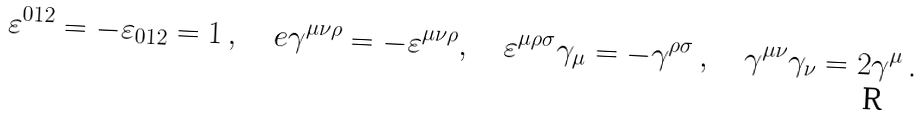Convert formula to latex. <formula><loc_0><loc_0><loc_500><loc_500>\varepsilon ^ { 0 1 2 } = - \varepsilon _ { 0 1 2 } = 1 \, , \quad e \gamma ^ { \mu \nu \rho } = - \varepsilon ^ { \mu \nu \rho } , \quad \varepsilon ^ { \mu \rho \sigma } \gamma _ { \mu } = - \gamma ^ { \rho \sigma } \, , \quad \gamma ^ { \mu \nu } \gamma _ { \nu } = 2 \gamma ^ { \mu } \, .</formula> 